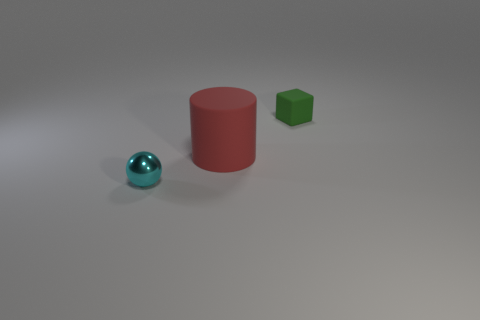What textures are present on the objects shown in the image? The objects in the image display distinct textures. The red cylinder and the green cube have a matte texture, suggesting they scatter light diffusely, while the blue sphere has a glossy or shiny texture, reflecting light in a more directed manner. 